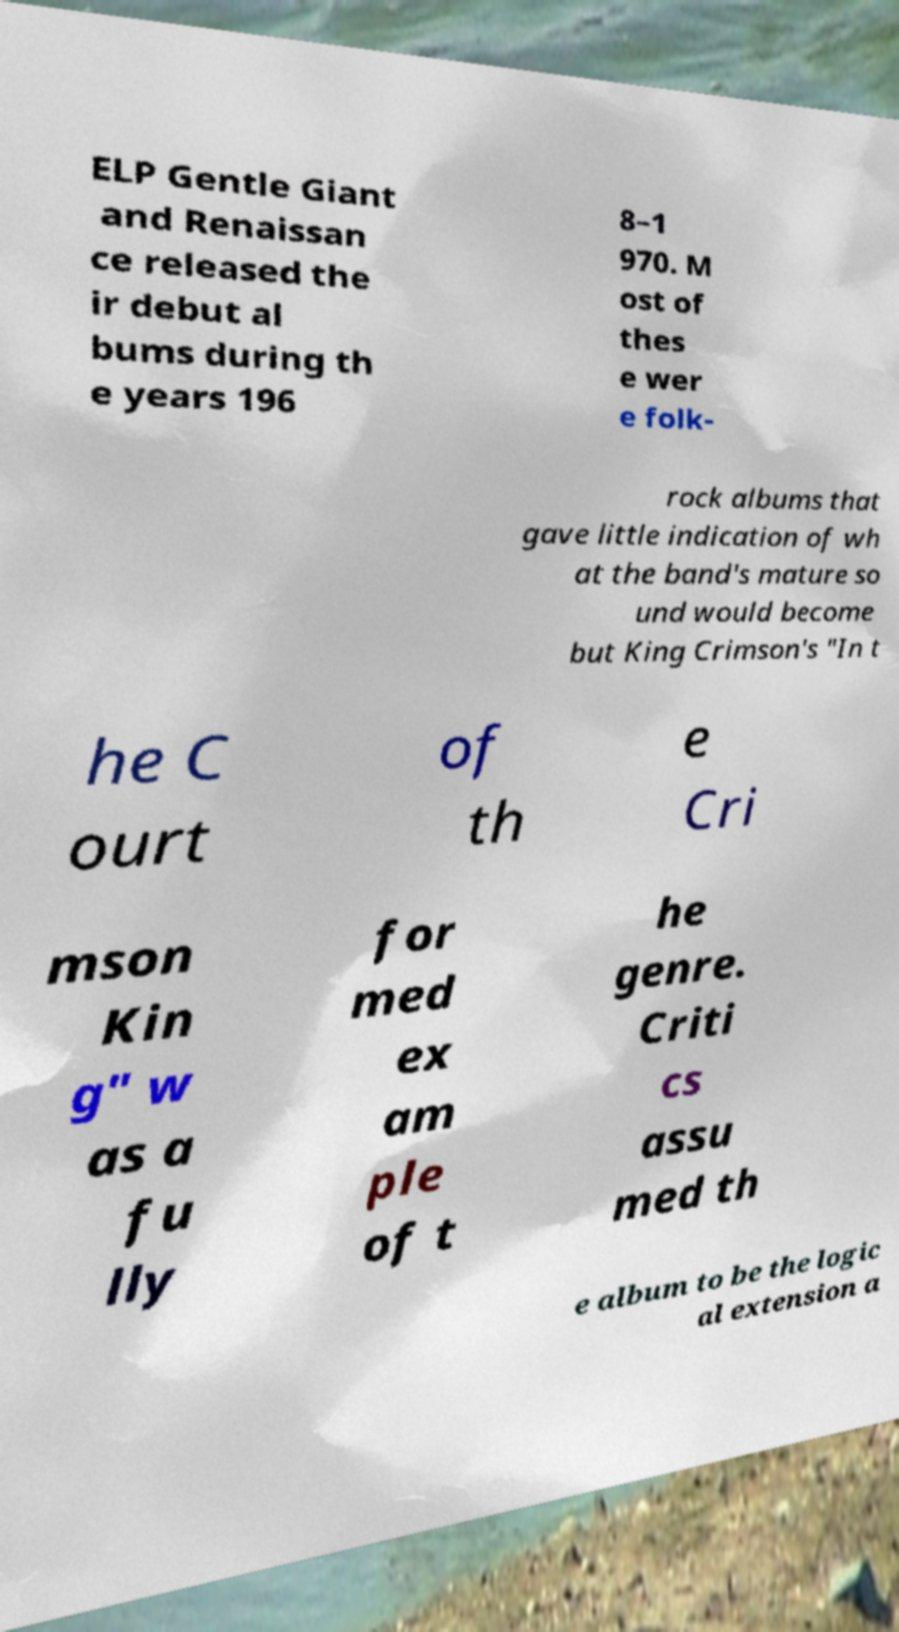Please read and relay the text visible in this image. What does it say? ELP Gentle Giant and Renaissan ce released the ir debut al bums during th e years 196 8–1 970. M ost of thes e wer e folk- rock albums that gave little indication of wh at the band's mature so und would become but King Crimson's "In t he C ourt of th e Cri mson Kin g" w as a fu lly for med ex am ple of t he genre. Criti cs assu med th e album to be the logic al extension a 